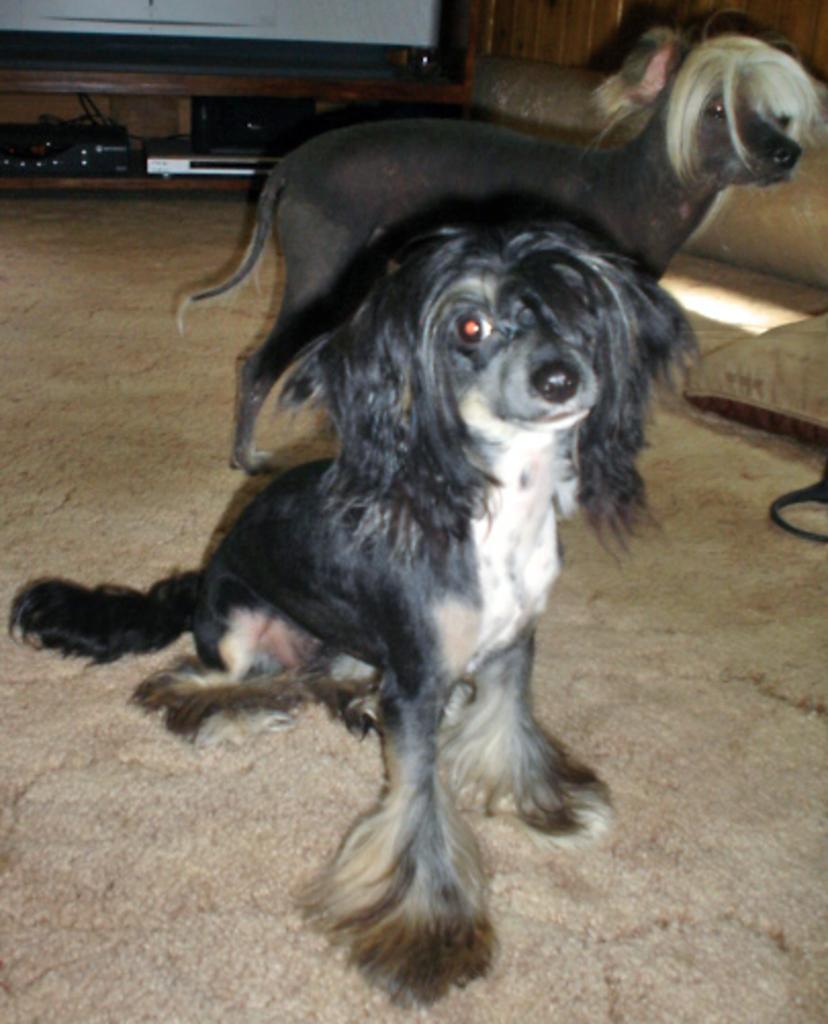In one or two sentences, can you explain what this image depicts? In the picture I can see two dogs among them the dog in front is sitting on the ground and the dog in the background is standing. These dogs are black in color. In the background I can see some objects on the floor. 